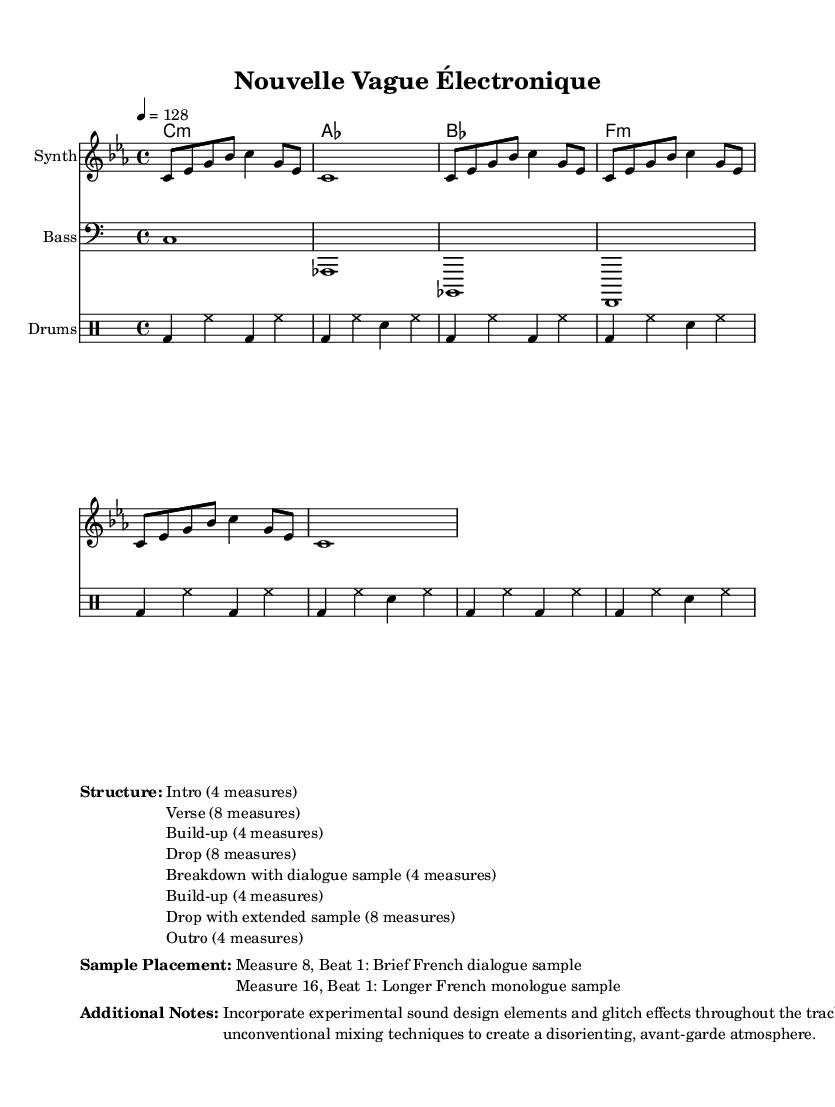What is the key signature of this music? The key signature is indicated by the `\key` command, which shows that the piece is in C minor, consisting of three flats (B♭, E♭, and A♭).
Answer: C minor What is the time signature of this music? The time signature is specified by the `\time` command, which shows that the music is in 4/4 time, meaning there are four beats in each measure and a quarter note gets one beat.
Answer: 4/4 What is the tempo marking of the piece? The tempo marking is indicated by `\tempo`, which specifies that the tempo is 128 beats per minute, meaning the main beats should be played at that speed.
Answer: 128 How many measures are in the `Breakdown with dialogue sample` section? The “Breakdown with dialogue sample” section is indicated in the structure markup and is described to last for 4 measures, which follows logically from the outlined sections of the music.
Answer: 4 What is the measure number where the brief French dialogue sample occurs? The placement for the brief French dialogue sample is specified in the sample placement markup as occurring at Measure 8, which is clearly stated in the document.
Answer: Measure 8 What type of effects are suggested to be used throughout the track? The additional notes section mentions integrating experimental sound design elements and glitch effects throughout the track, which contributes to the avant-garde atmosphere intended for the piece.
Answer: Glitch effects What is the instrument name for the melody staff? The instrument name for the melody staff is specified in the `\new Staff` command, where the instrument is clearly labeled as "Synth."
Answer: Synth 